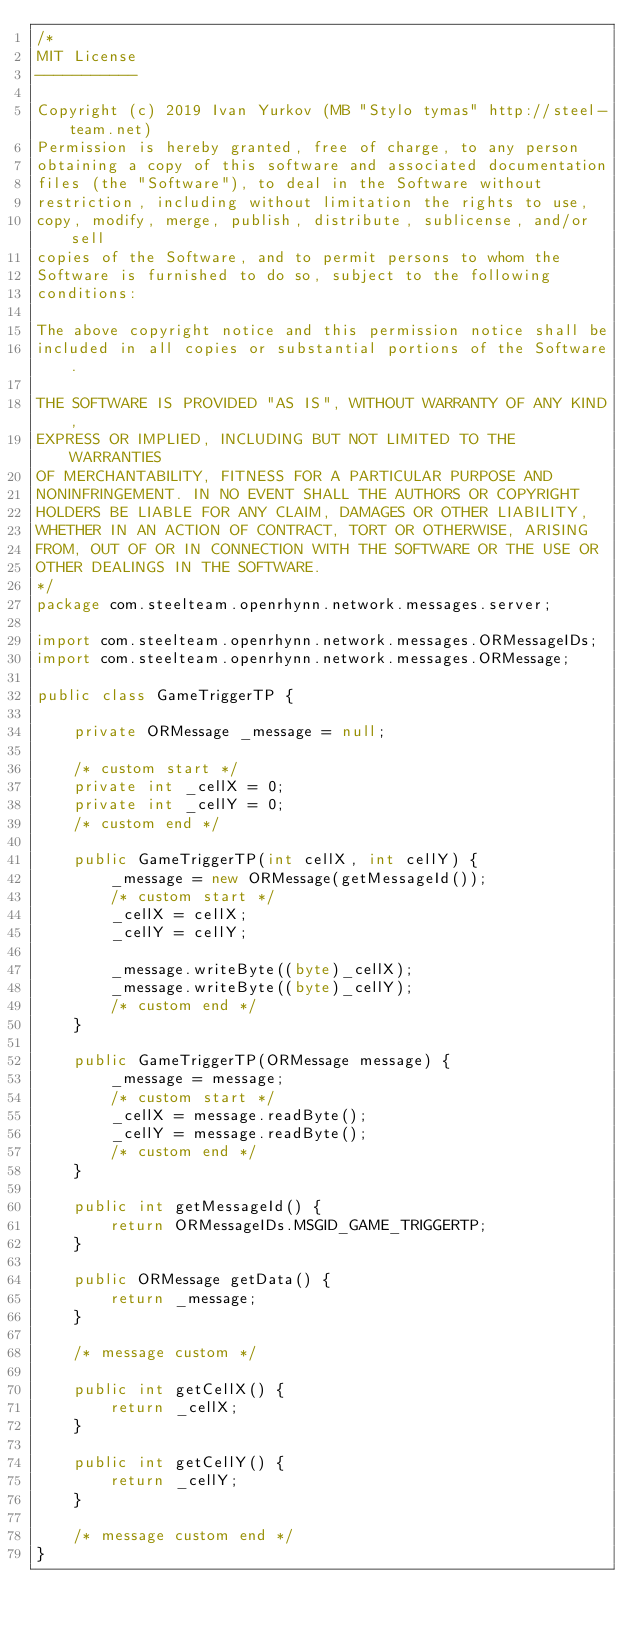Convert code to text. <code><loc_0><loc_0><loc_500><loc_500><_Java_>/*
MIT License
-----------

Copyright (c) 2019 Ivan Yurkov (MB "Stylo tymas" http://steel-team.net)
Permission is hereby granted, free of charge, to any person
obtaining a copy of this software and associated documentation
files (the "Software"), to deal in the Software without
restriction, including without limitation the rights to use,
copy, modify, merge, publish, distribute, sublicense, and/or sell
copies of the Software, and to permit persons to whom the
Software is furnished to do so, subject to the following
conditions:

The above copyright notice and this permission notice shall be
included in all copies or substantial portions of the Software.

THE SOFTWARE IS PROVIDED "AS IS", WITHOUT WARRANTY OF ANY KIND,
EXPRESS OR IMPLIED, INCLUDING BUT NOT LIMITED TO THE WARRANTIES
OF MERCHANTABILITY, FITNESS FOR A PARTICULAR PURPOSE AND
NONINFRINGEMENT. IN NO EVENT SHALL THE AUTHORS OR COPYRIGHT
HOLDERS BE LIABLE FOR ANY CLAIM, DAMAGES OR OTHER LIABILITY,
WHETHER IN AN ACTION OF CONTRACT, TORT OR OTHERWISE, ARISING
FROM, OUT OF OR IN CONNECTION WITH THE SOFTWARE OR THE USE OR
OTHER DEALINGS IN THE SOFTWARE.
*/
package com.steelteam.openrhynn.network.messages.server;

import com.steelteam.openrhynn.network.messages.ORMessageIDs;
import com.steelteam.openrhynn.network.messages.ORMessage;

public class GameTriggerTP {

    private ORMessage _message = null;

    /* custom start */
    private int _cellX = 0;
    private int _cellY = 0;
    /* custom end */

    public GameTriggerTP(int cellX, int cellY) {
        _message = new ORMessage(getMessageId());
        /* custom start */
        _cellX = cellX;
        _cellY = cellY;

        _message.writeByte((byte)_cellX);
        _message.writeByte((byte)_cellY);
        /* custom end */
    }

    public GameTriggerTP(ORMessage message) {
        _message = message;
        /* custom start */
        _cellX = message.readByte();
        _cellY = message.readByte();
        /* custom end */
    }

    public int getMessageId() {
        return ORMessageIDs.MSGID_GAME_TRIGGERTP;
    }

    public ORMessage getData() {
        return _message;
    }

    /* message custom */

    public int getCellX() {
        return _cellX;
    }

    public int getCellY() {
        return _cellY;
    }

    /* message custom end */
}
</code> 